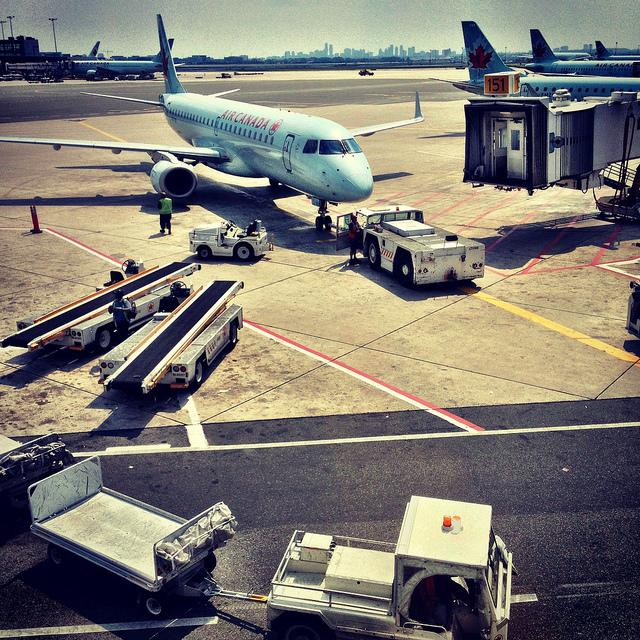What does the vehicle that will be used to move the plane face? plane 